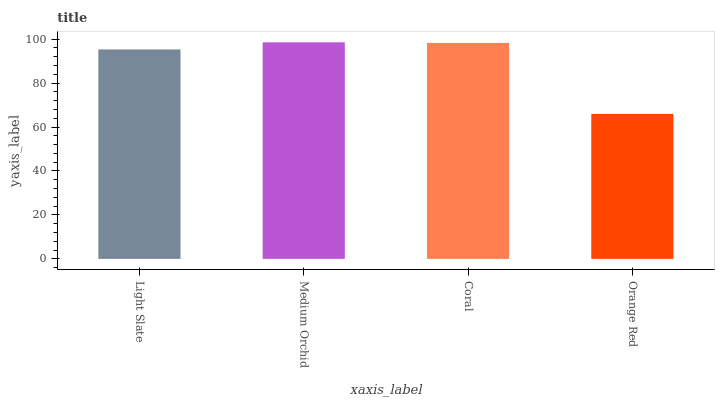Is Orange Red the minimum?
Answer yes or no. Yes. Is Medium Orchid the maximum?
Answer yes or no. Yes. Is Coral the minimum?
Answer yes or no. No. Is Coral the maximum?
Answer yes or no. No. Is Medium Orchid greater than Coral?
Answer yes or no. Yes. Is Coral less than Medium Orchid?
Answer yes or no. Yes. Is Coral greater than Medium Orchid?
Answer yes or no. No. Is Medium Orchid less than Coral?
Answer yes or no. No. Is Coral the high median?
Answer yes or no. Yes. Is Light Slate the low median?
Answer yes or no. Yes. Is Light Slate the high median?
Answer yes or no. No. Is Orange Red the low median?
Answer yes or no. No. 